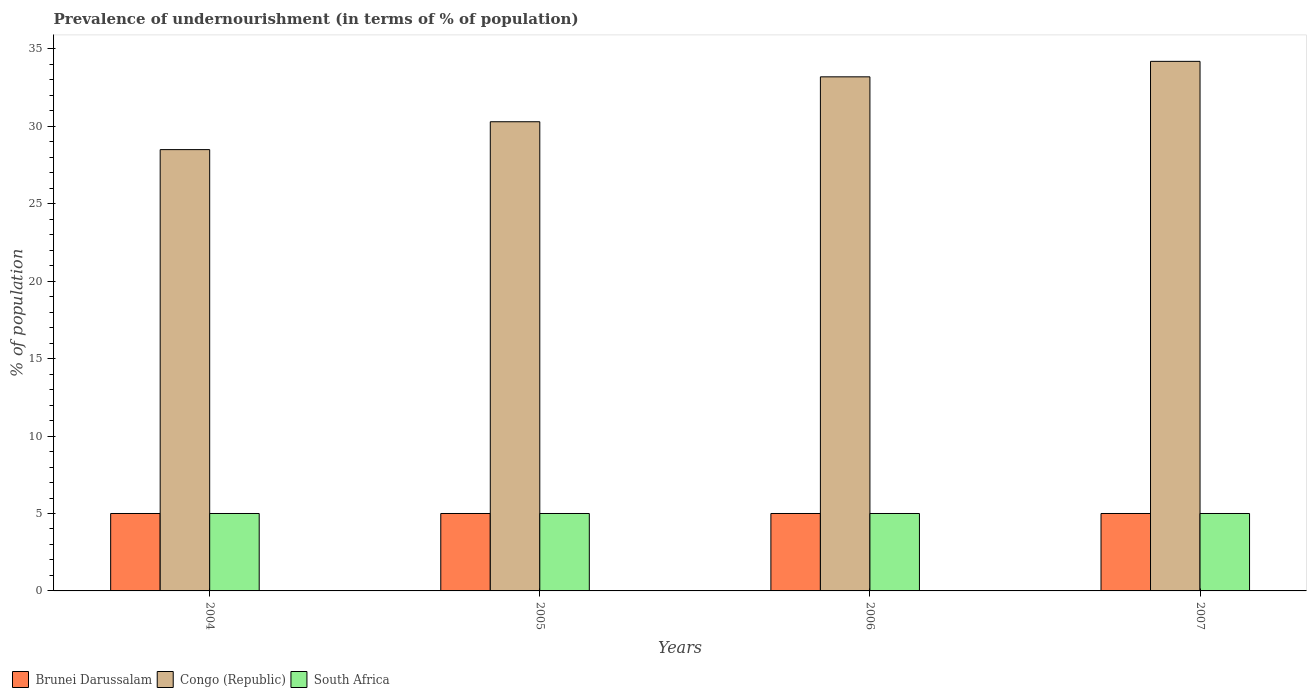How many different coloured bars are there?
Keep it short and to the point. 3. How many bars are there on the 1st tick from the left?
Offer a terse response. 3. How many bars are there on the 4th tick from the right?
Your answer should be very brief. 3. In how many cases, is the number of bars for a given year not equal to the number of legend labels?
Give a very brief answer. 0. What is the percentage of undernourished population in Congo (Republic) in 2005?
Your answer should be very brief. 30.3. Across all years, what is the maximum percentage of undernourished population in Brunei Darussalam?
Give a very brief answer. 5. What is the total percentage of undernourished population in Brunei Darussalam in the graph?
Your answer should be compact. 20. What is the difference between the percentage of undernourished population in South Africa in 2006 and the percentage of undernourished population in Congo (Republic) in 2004?
Make the answer very short. -23.5. What is the average percentage of undernourished population in Congo (Republic) per year?
Give a very brief answer. 31.55. In the year 2005, what is the difference between the percentage of undernourished population in Brunei Darussalam and percentage of undernourished population in South Africa?
Your response must be concise. 0. In how many years, is the percentage of undernourished population in South Africa greater than 9 %?
Give a very brief answer. 0. What is the ratio of the percentage of undernourished population in South Africa in 2004 to that in 2007?
Your answer should be very brief. 1. Is the percentage of undernourished population in South Africa in 2004 less than that in 2007?
Make the answer very short. No. Is the difference between the percentage of undernourished population in Brunei Darussalam in 2005 and 2006 greater than the difference between the percentage of undernourished population in South Africa in 2005 and 2006?
Your answer should be compact. No. What is the difference between the highest and the lowest percentage of undernourished population in Brunei Darussalam?
Provide a short and direct response. 0. In how many years, is the percentage of undernourished population in South Africa greater than the average percentage of undernourished population in South Africa taken over all years?
Keep it short and to the point. 0. Is the sum of the percentage of undernourished population in Congo (Republic) in 2005 and 2006 greater than the maximum percentage of undernourished population in Brunei Darussalam across all years?
Provide a succinct answer. Yes. What does the 2nd bar from the left in 2005 represents?
Offer a very short reply. Congo (Republic). What does the 2nd bar from the right in 2005 represents?
Give a very brief answer. Congo (Republic). How many bars are there?
Give a very brief answer. 12. Are all the bars in the graph horizontal?
Your answer should be very brief. No. Does the graph contain grids?
Provide a short and direct response. No. Where does the legend appear in the graph?
Offer a terse response. Bottom left. How many legend labels are there?
Make the answer very short. 3. What is the title of the graph?
Provide a short and direct response. Prevalence of undernourishment (in terms of % of population). What is the label or title of the Y-axis?
Offer a very short reply. % of population. What is the % of population of South Africa in 2004?
Your answer should be very brief. 5. What is the % of population in Congo (Republic) in 2005?
Offer a very short reply. 30.3. What is the % of population of South Africa in 2005?
Your answer should be compact. 5. What is the % of population in Brunei Darussalam in 2006?
Your response must be concise. 5. What is the % of population in Congo (Republic) in 2006?
Offer a terse response. 33.2. What is the % of population in South Africa in 2006?
Give a very brief answer. 5. What is the % of population of Brunei Darussalam in 2007?
Offer a terse response. 5. What is the % of population in Congo (Republic) in 2007?
Your answer should be compact. 34.2. What is the % of population in South Africa in 2007?
Offer a terse response. 5. Across all years, what is the maximum % of population in Congo (Republic)?
Keep it short and to the point. 34.2. Across all years, what is the minimum % of population in Brunei Darussalam?
Ensure brevity in your answer.  5. What is the total % of population in Congo (Republic) in the graph?
Your answer should be compact. 126.2. What is the difference between the % of population in Brunei Darussalam in 2004 and that in 2005?
Your response must be concise. 0. What is the difference between the % of population in Congo (Republic) in 2004 and that in 2005?
Provide a succinct answer. -1.8. What is the difference between the % of population in Congo (Republic) in 2004 and that in 2006?
Make the answer very short. -4.7. What is the difference between the % of population of South Africa in 2004 and that in 2006?
Provide a succinct answer. 0. What is the difference between the % of population of Congo (Republic) in 2005 and that in 2007?
Ensure brevity in your answer.  -3.9. What is the difference between the % of population of South Africa in 2005 and that in 2007?
Ensure brevity in your answer.  0. What is the difference between the % of population of Brunei Darussalam in 2006 and that in 2007?
Make the answer very short. 0. What is the difference between the % of population of Congo (Republic) in 2006 and that in 2007?
Provide a short and direct response. -1. What is the difference between the % of population in South Africa in 2006 and that in 2007?
Give a very brief answer. 0. What is the difference between the % of population of Brunei Darussalam in 2004 and the % of population of Congo (Republic) in 2005?
Your response must be concise. -25.3. What is the difference between the % of population of Congo (Republic) in 2004 and the % of population of South Africa in 2005?
Ensure brevity in your answer.  23.5. What is the difference between the % of population of Brunei Darussalam in 2004 and the % of population of Congo (Republic) in 2006?
Make the answer very short. -28.2. What is the difference between the % of population in Congo (Republic) in 2004 and the % of population in South Africa in 2006?
Your response must be concise. 23.5. What is the difference between the % of population of Brunei Darussalam in 2004 and the % of population of Congo (Republic) in 2007?
Offer a terse response. -29.2. What is the difference between the % of population of Congo (Republic) in 2004 and the % of population of South Africa in 2007?
Ensure brevity in your answer.  23.5. What is the difference between the % of population in Brunei Darussalam in 2005 and the % of population in Congo (Republic) in 2006?
Your response must be concise. -28.2. What is the difference between the % of population in Congo (Republic) in 2005 and the % of population in South Africa in 2006?
Give a very brief answer. 25.3. What is the difference between the % of population in Brunei Darussalam in 2005 and the % of population in Congo (Republic) in 2007?
Ensure brevity in your answer.  -29.2. What is the difference between the % of population of Brunei Darussalam in 2005 and the % of population of South Africa in 2007?
Give a very brief answer. 0. What is the difference between the % of population in Congo (Republic) in 2005 and the % of population in South Africa in 2007?
Your answer should be very brief. 25.3. What is the difference between the % of population of Brunei Darussalam in 2006 and the % of population of Congo (Republic) in 2007?
Provide a succinct answer. -29.2. What is the difference between the % of population in Congo (Republic) in 2006 and the % of population in South Africa in 2007?
Ensure brevity in your answer.  28.2. What is the average % of population of Brunei Darussalam per year?
Provide a succinct answer. 5. What is the average % of population of Congo (Republic) per year?
Your answer should be compact. 31.55. What is the average % of population of South Africa per year?
Offer a very short reply. 5. In the year 2004, what is the difference between the % of population in Brunei Darussalam and % of population in Congo (Republic)?
Keep it short and to the point. -23.5. In the year 2004, what is the difference between the % of population in Brunei Darussalam and % of population in South Africa?
Give a very brief answer. 0. In the year 2004, what is the difference between the % of population of Congo (Republic) and % of population of South Africa?
Offer a very short reply. 23.5. In the year 2005, what is the difference between the % of population in Brunei Darussalam and % of population in Congo (Republic)?
Your response must be concise. -25.3. In the year 2005, what is the difference between the % of population in Brunei Darussalam and % of population in South Africa?
Ensure brevity in your answer.  0. In the year 2005, what is the difference between the % of population of Congo (Republic) and % of population of South Africa?
Provide a succinct answer. 25.3. In the year 2006, what is the difference between the % of population of Brunei Darussalam and % of population of Congo (Republic)?
Offer a terse response. -28.2. In the year 2006, what is the difference between the % of population in Brunei Darussalam and % of population in South Africa?
Keep it short and to the point. 0. In the year 2006, what is the difference between the % of population of Congo (Republic) and % of population of South Africa?
Keep it short and to the point. 28.2. In the year 2007, what is the difference between the % of population of Brunei Darussalam and % of population of Congo (Republic)?
Provide a short and direct response. -29.2. In the year 2007, what is the difference between the % of population in Brunei Darussalam and % of population in South Africa?
Ensure brevity in your answer.  0. In the year 2007, what is the difference between the % of population of Congo (Republic) and % of population of South Africa?
Keep it short and to the point. 29.2. What is the ratio of the % of population of Congo (Republic) in 2004 to that in 2005?
Give a very brief answer. 0.94. What is the ratio of the % of population in Congo (Republic) in 2004 to that in 2006?
Provide a short and direct response. 0.86. What is the ratio of the % of population of South Africa in 2004 to that in 2006?
Make the answer very short. 1. What is the ratio of the % of population in Congo (Republic) in 2004 to that in 2007?
Make the answer very short. 0.83. What is the ratio of the % of population in South Africa in 2004 to that in 2007?
Make the answer very short. 1. What is the ratio of the % of population in Congo (Republic) in 2005 to that in 2006?
Ensure brevity in your answer.  0.91. What is the ratio of the % of population in South Africa in 2005 to that in 2006?
Keep it short and to the point. 1. What is the ratio of the % of population in Brunei Darussalam in 2005 to that in 2007?
Make the answer very short. 1. What is the ratio of the % of population of Congo (Republic) in 2005 to that in 2007?
Ensure brevity in your answer.  0.89. What is the ratio of the % of population in Brunei Darussalam in 2006 to that in 2007?
Make the answer very short. 1. What is the ratio of the % of population of Congo (Republic) in 2006 to that in 2007?
Offer a very short reply. 0.97. What is the ratio of the % of population in South Africa in 2006 to that in 2007?
Give a very brief answer. 1. What is the difference between the highest and the second highest % of population in Congo (Republic)?
Offer a very short reply. 1. What is the difference between the highest and the lowest % of population in Congo (Republic)?
Provide a succinct answer. 5.7. What is the difference between the highest and the lowest % of population of South Africa?
Give a very brief answer. 0. 